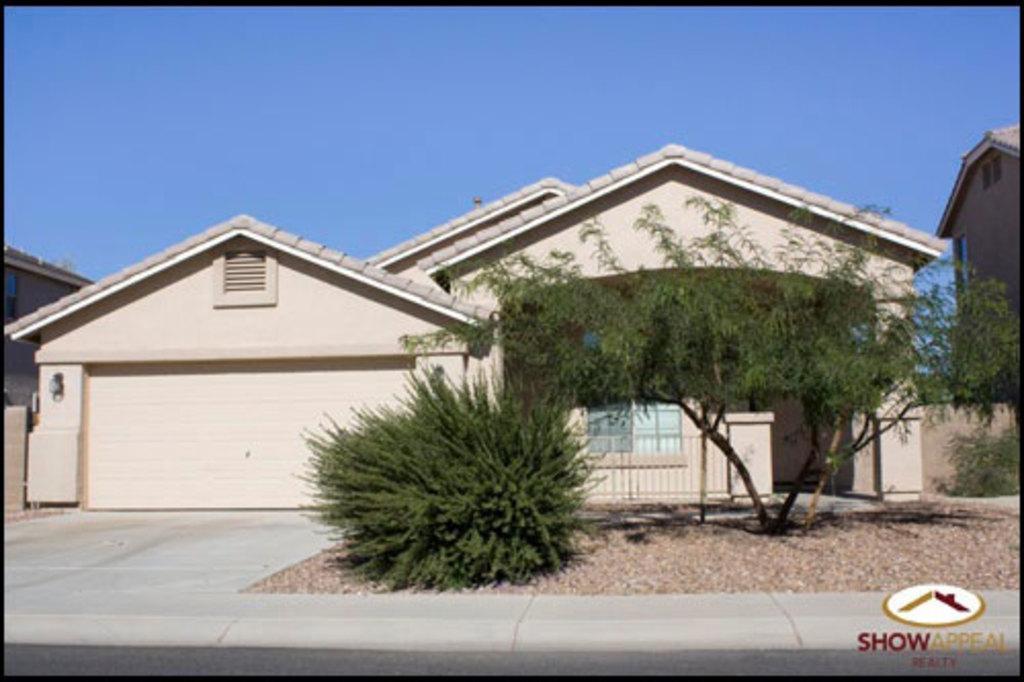Please provide a concise description of this image. In this image I can see few trees in green color, background I can see few buildings in cream and brown color and the sky is in blue color. 